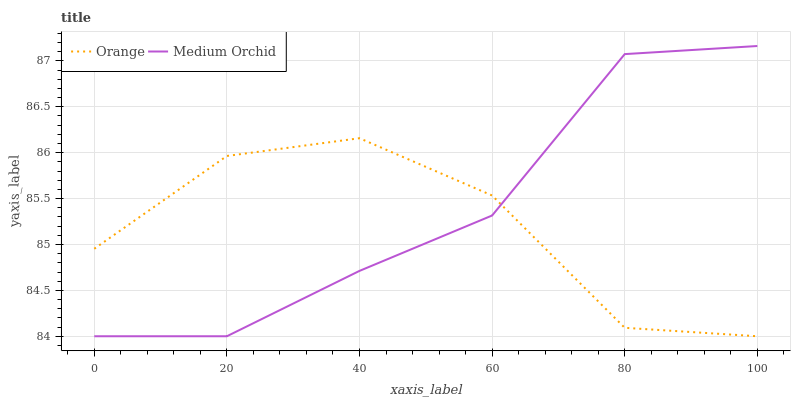Does Orange have the minimum area under the curve?
Answer yes or no. Yes. Does Medium Orchid have the maximum area under the curve?
Answer yes or no. Yes. Does Medium Orchid have the minimum area under the curve?
Answer yes or no. No. Is Medium Orchid the smoothest?
Answer yes or no. Yes. Is Orange the roughest?
Answer yes or no. Yes. Is Medium Orchid the roughest?
Answer yes or no. No. Does Medium Orchid have the highest value?
Answer yes or no. Yes. Does Orange intersect Medium Orchid?
Answer yes or no. Yes. Is Orange less than Medium Orchid?
Answer yes or no. No. Is Orange greater than Medium Orchid?
Answer yes or no. No. 